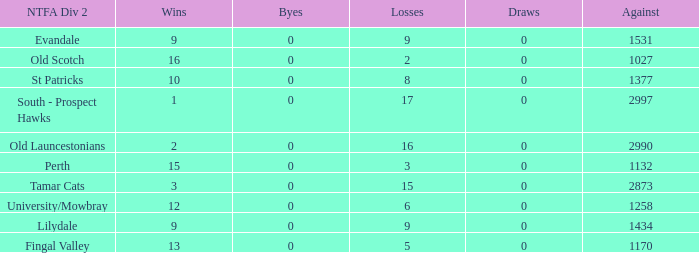What is the lowest number of draws of the team with 9 wins and less than 0 byes? None. 